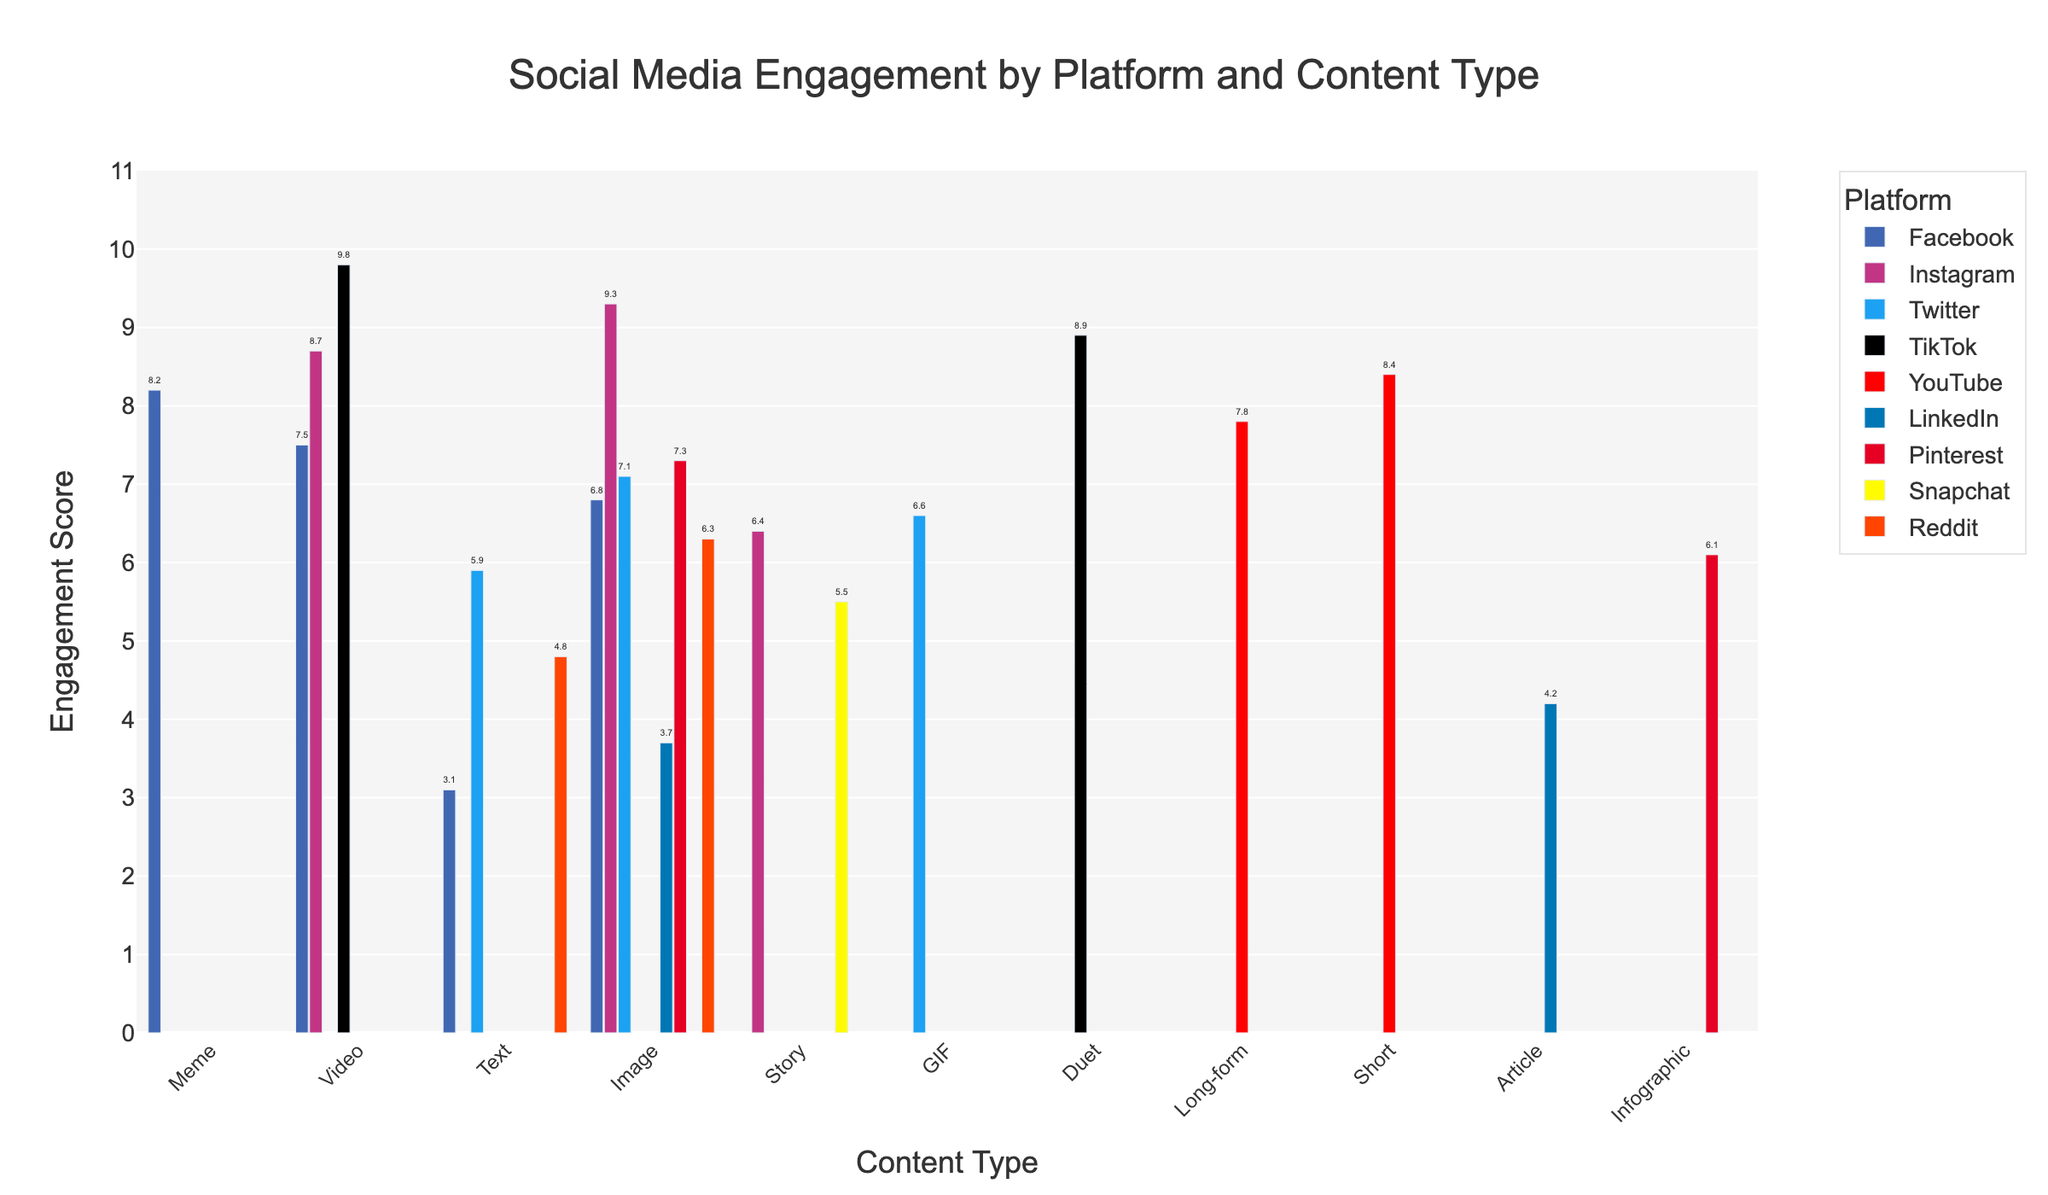What is the highest engagement score for TikTok? The TikTok segment includes "Video" and "Duet" content types. By examining the figure, the "Video" content type reaches 9.8, which is the highest.
Answer: 9.8 What platform has the lowest engagement score for Text content? The platforms displaying Text content are Facebook, Twitter, and Reddit. Among these, Facebook Text has the lowest score of 3.1.
Answer: Facebook How many content types are there in total for all platforms? By counting the distinct bars representing content types across all platforms in the figure, we find 20 distinct content types.
Answer: 20 Which platform and content type combination has the highest engagement score? The platform with the highest engagement score can be found by identifying the tallest bar. TikTok Video has the highest score of 9.8.
Answer: TikTok Video What is the average engagement score across all different content types on Instagram? Instagram has three content types: Image (9.3), Video (8.7), and Story (6.4). Adding these gives a total of 24.4, and the average is 24.4 / 3 = 8.133.
Answer: 8.1 Is the average engagement score for YouTube content higher or lower than LinkedIn content? YouTube content scores are 7.8 (Long-form) and 8.4 (Short), averaging 8.1. LinkedIn content scores are 4.2 (Article) and 3.7 (Image), averaging 3.95. Comparing averages, YouTube's average score is higher.
Answer: Higher Which content type appears to have the most consistent engagement scores across different platforms? Observing the engagement scores of each content type across platforms, Image content appears on multiple platforms (Facebook, Instagram, Twitter, LinkedIn, Pinterest, Reddit) with scores ranging from around 3.7 to 9.3. While this range might seem wide, the majority cluster around mid to high engagement scores, indicating relative consistency compared to other types like Text or Video with wider dispersions.
Answer: Image Which platform shows the highest diversity in engagement scores across its different content types? By identifying the biggest range in scores within a platform, Facebook varies from 3.1 (Text) to 8.2 (Meme). This range (5.1) is larger compared to other platforms, indicating higher diversity.
Answer: Facebook How does Pinterest's engagement score for Image content compare to Instagram's score for the same? Pinterest's Image content scores 7.3, while Instagram's Image content scores 9.3. Comparing these, Instagram's score is higher.
Answer: Higher What is the engagement score for LinkedIn's Article content type? Moving to LinkedIn and focusing on Article, the engagement score is visible as 4.2.
Answer: 4.2 